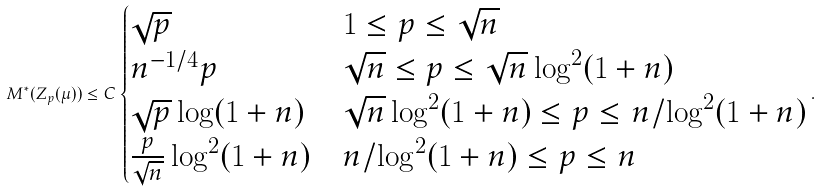<formula> <loc_0><loc_0><loc_500><loc_500>M ^ { * } ( Z _ { p } ( \mu ) ) \leq C \begin{cases} \sqrt { p } & 1 \leq p \leq \sqrt { n } \\ n ^ { - 1 / 4 } p & \sqrt { n } \leq p \leq \sqrt { n } \log ^ { 2 } ( 1 + n ) \\ \sqrt { p } \log ( 1 + n ) & \sqrt { n } \log ^ { 2 } ( 1 + n ) \leq p \leq n / \log ^ { 2 } ( 1 + n ) \\ \frac { p } { \sqrt { n } } \log ^ { 2 } ( 1 + n ) & n / \log ^ { 2 } ( 1 + n ) \leq p \leq n \end{cases} .</formula> 